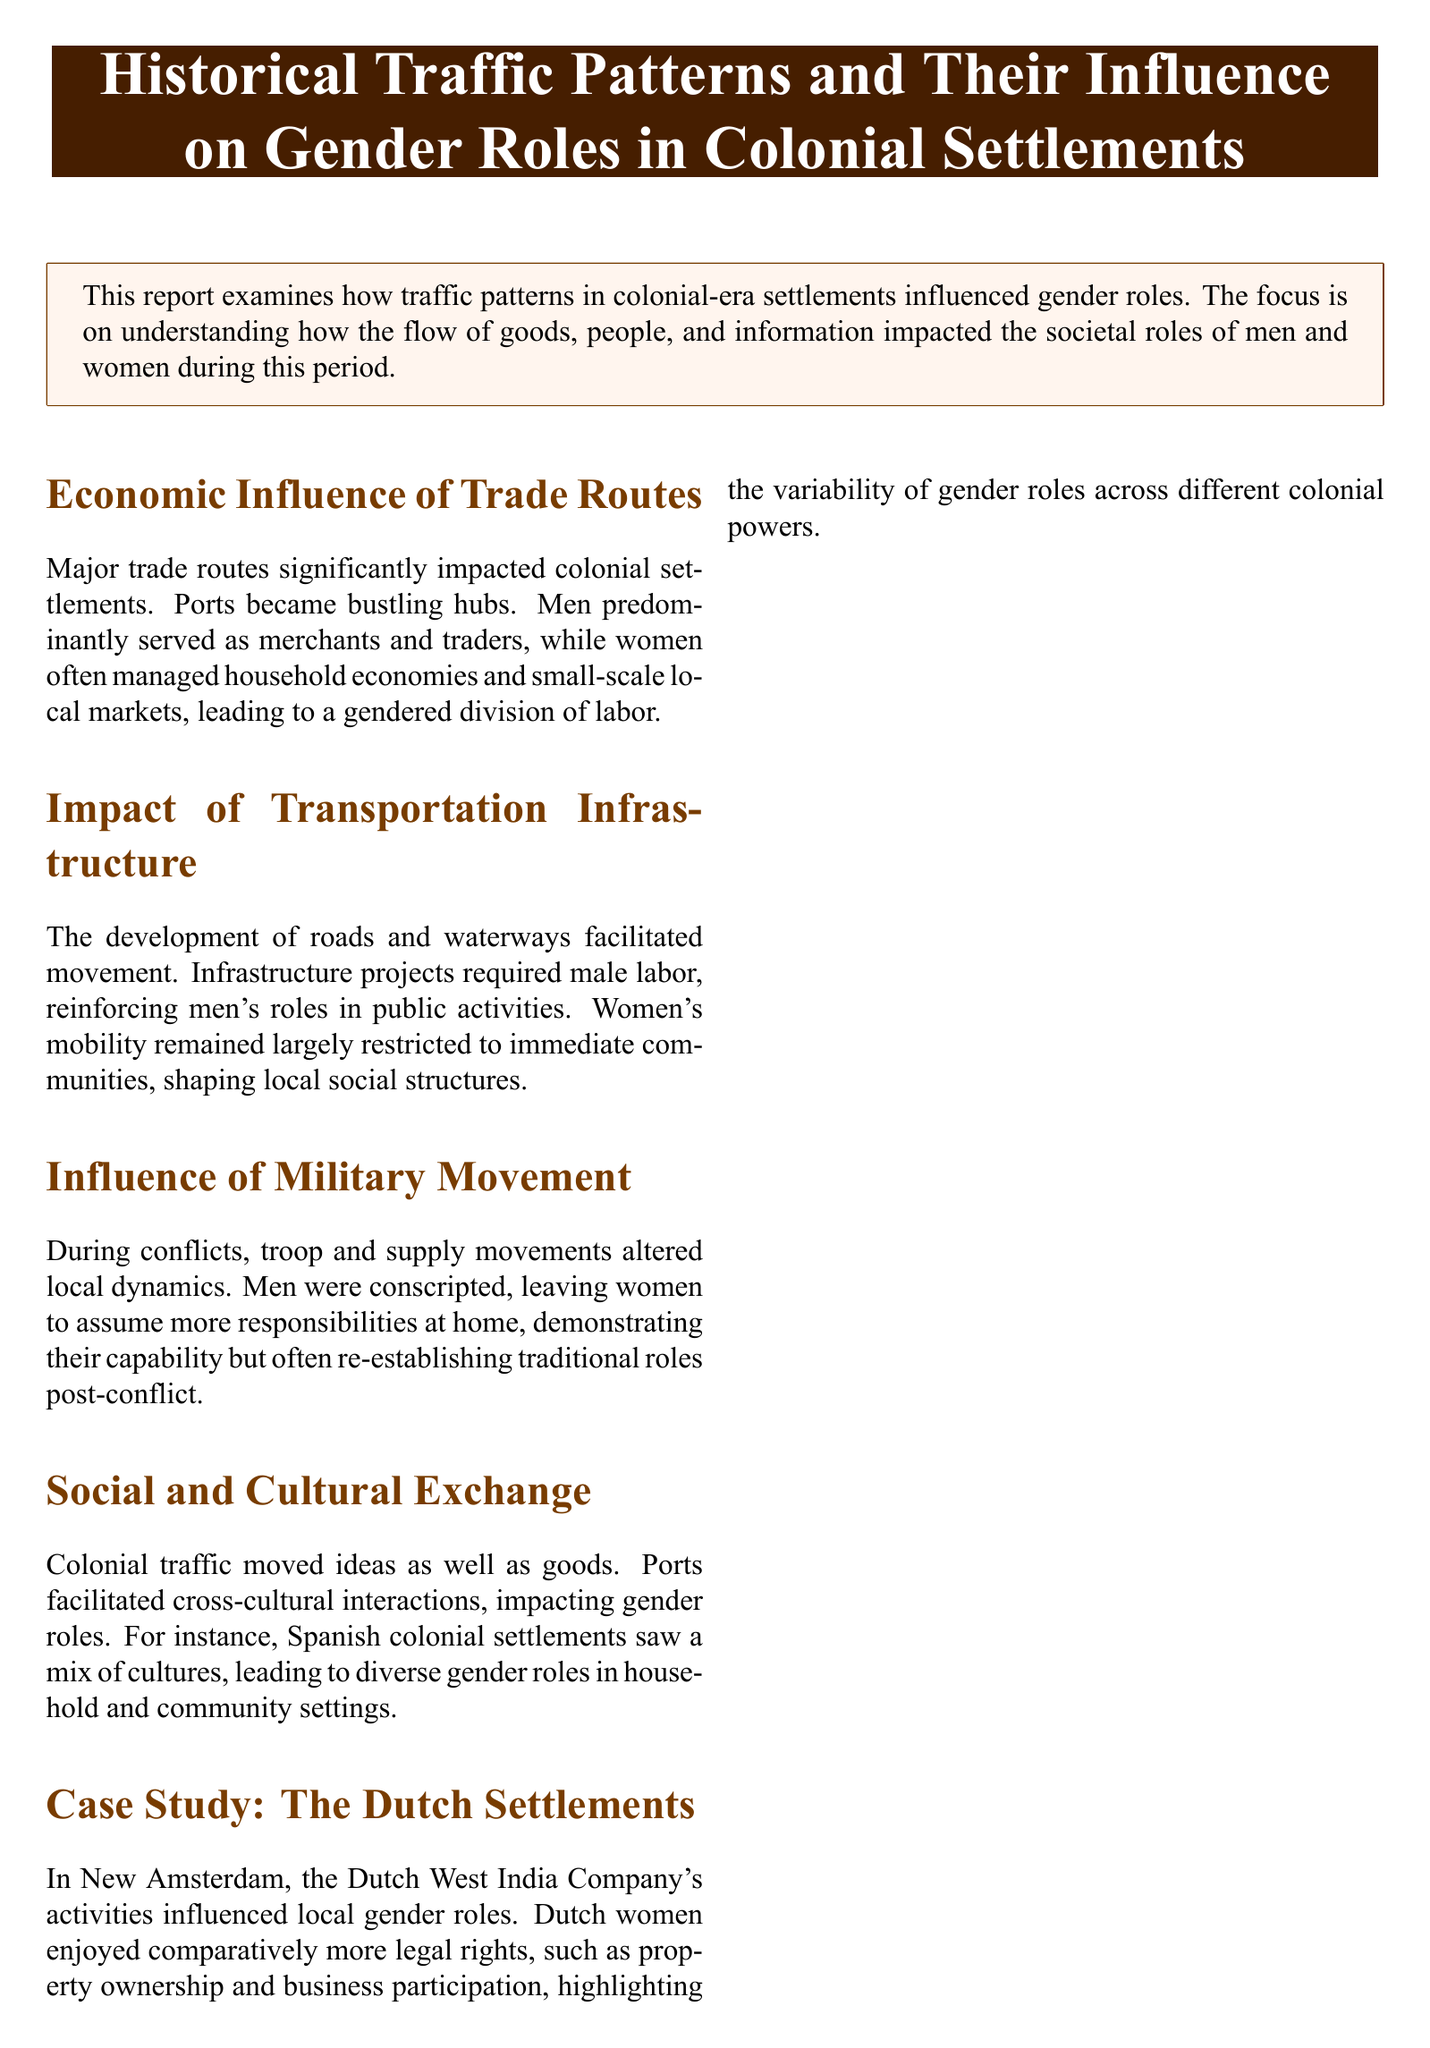What was the major impact of trade routes in colonial settlements? Trade routes significantly impacted colonial settlements by establishing bustling ports where men predominantly served as merchants and traders.
Answer: bustling ports How did military movements affect women's roles during conflicts? Military movements led to men being conscripted, leaving women to assume more responsibilities at home, demonstrating their capability.
Answer: more responsibilities In which settlement did Dutch women enjoy comparatively more legal rights? The case study highlights New Amsterdam, where women had legal rights like property ownership and business participation.
Answer: New Amsterdam What was the primary focus of the report? The report focuses on understanding how the flow of goods, people, and information impacted the societal roles of men and women during colonial times.
Answer: societal roles What facilitated the movement in colonial settlements? The development of roads and waterways facilitated movement in colonial settlements.
Answer: roads and waterways What influenced local gender roles in Spanish colonial settlements? The mix of cultures facilitated by colonial traffic led to diverse gender roles in household and community settings.
Answer: cultural mix What type of labor was required for infrastructure projects? Infrastructure projects required male labor.
Answer: male labor How did colonial traffic contribute to gender roles? It moved ideas as well as goods, affecting societal roles during the colonial era.
Answer: moved ideas Which colonial power is mentioned for having variability in gender roles? The Dutch are specifically noted for having variability in gender roles in their settlements.
Answer: Dutch 